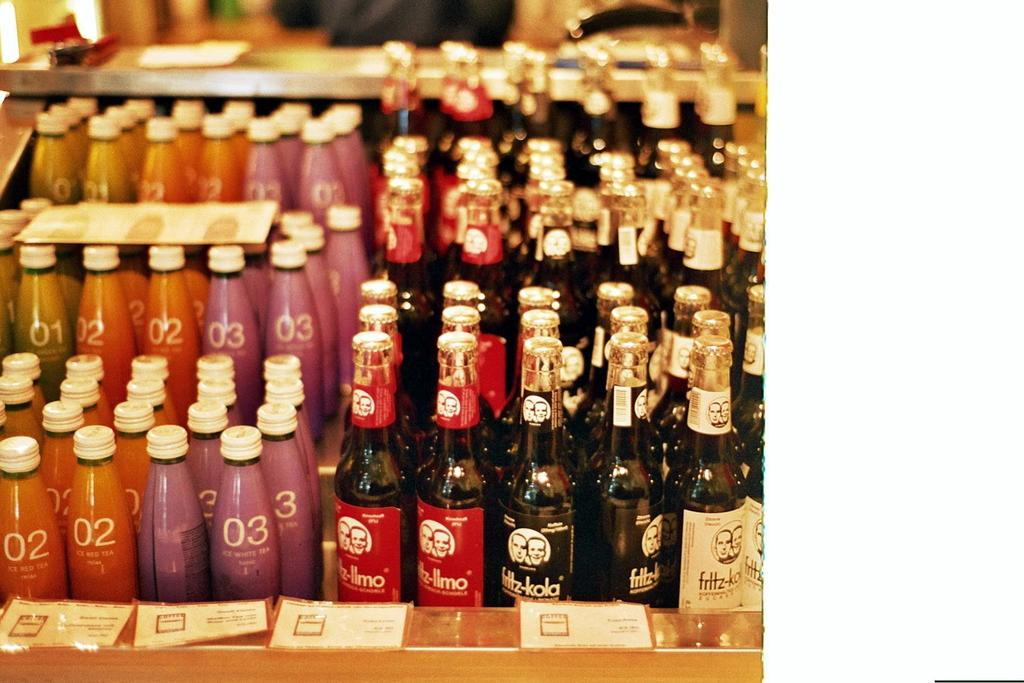Provide a one-sentence caption for the provided image. A large display of bottled beverages including many of the Fritz-kola brand. 